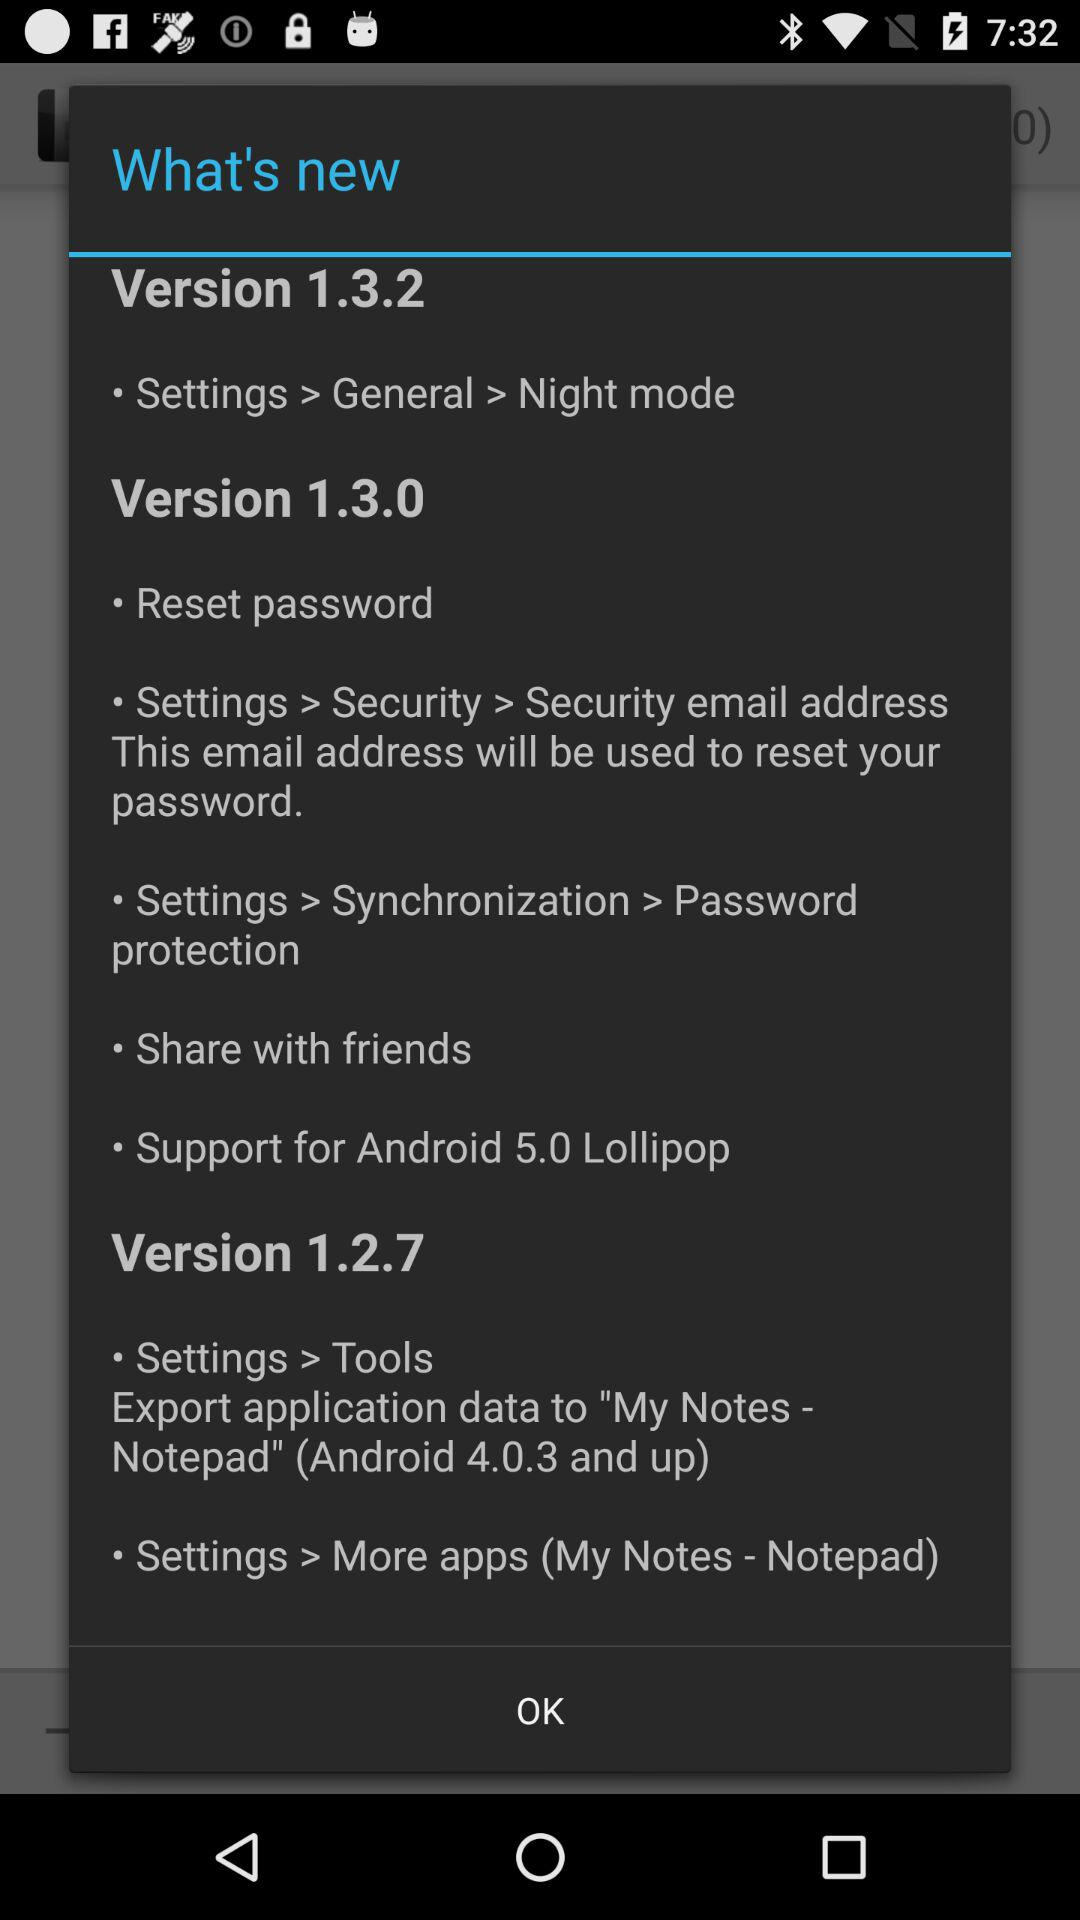Which operating systems are supported by version 1.3.0? The supported operating system is "Android 5.0 Lollipop". 